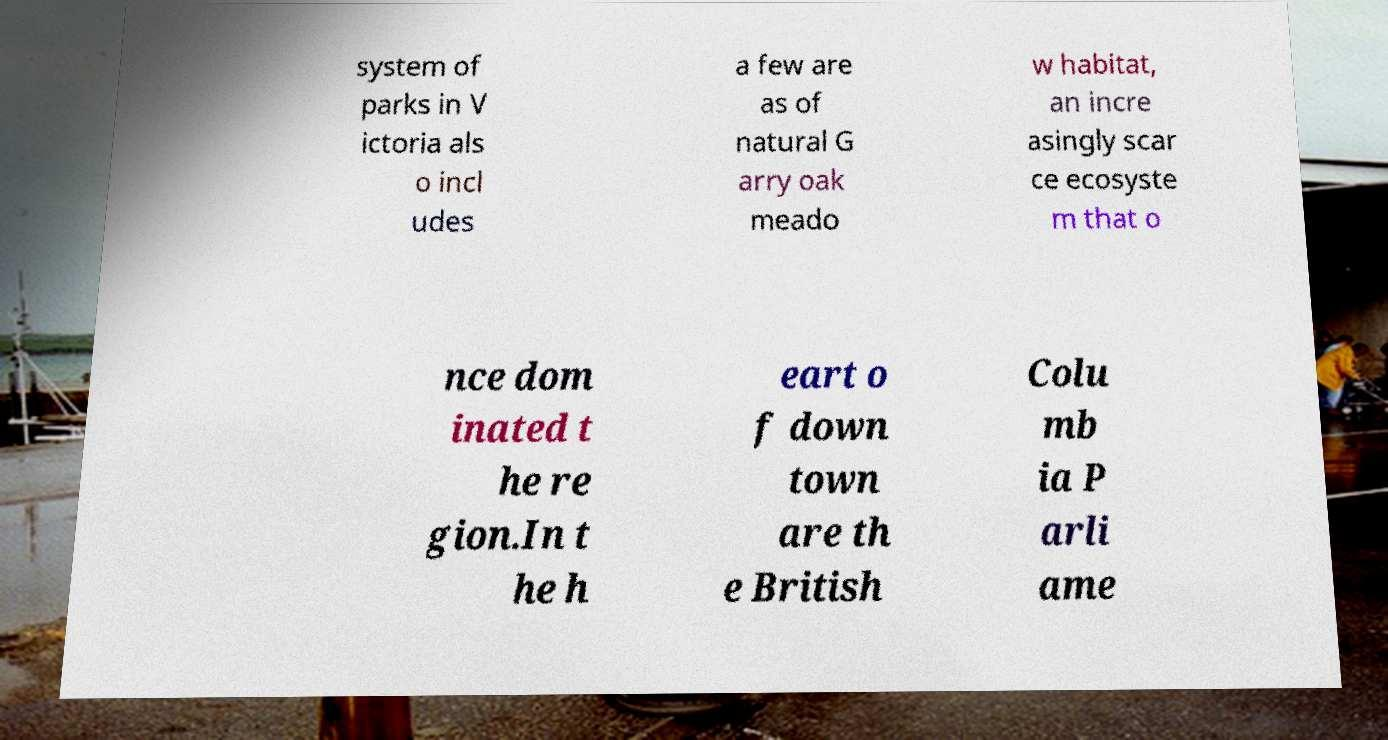What messages or text are displayed in this image? I need them in a readable, typed format. system of parks in V ictoria als o incl udes a few are as of natural G arry oak meado w habitat, an incre asingly scar ce ecosyste m that o nce dom inated t he re gion.In t he h eart o f down town are th e British Colu mb ia P arli ame 